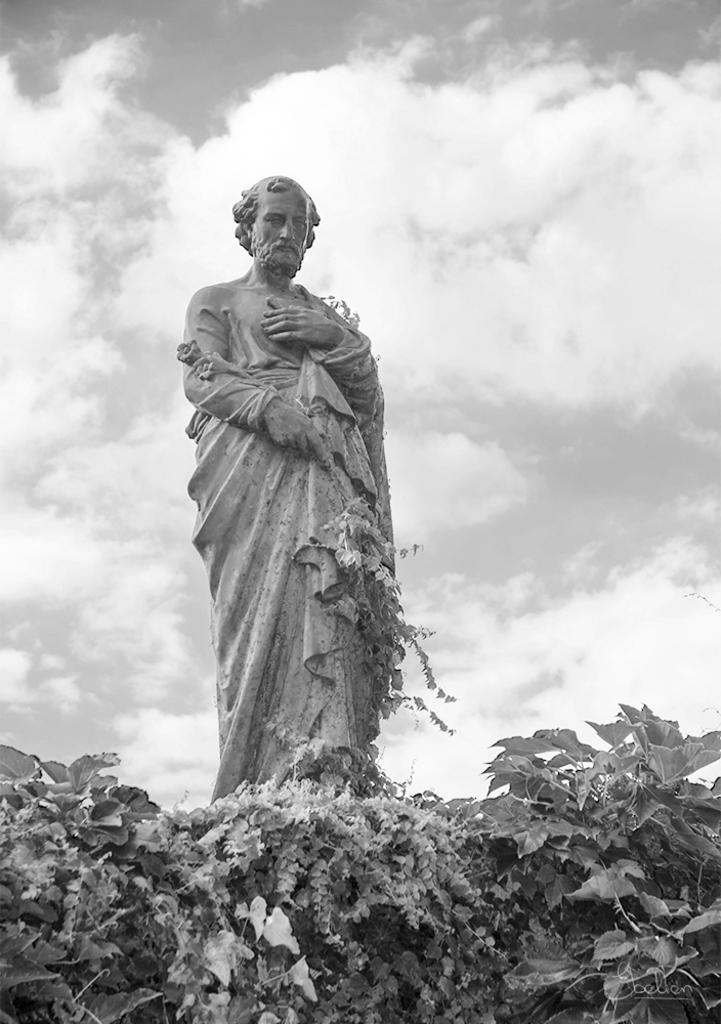What is the main subject in the image? There is a statue in the image. What else can be seen in the image besides the statue? There are plants and clouds visible in the image. What is the color scheme of the image? The image is in black and white. Can you describe the fight between the yarn and the whip in the image? There is no fight between yarn and a whip present in the image, as it only features a statue, plants, clouds, and is in black and white. 